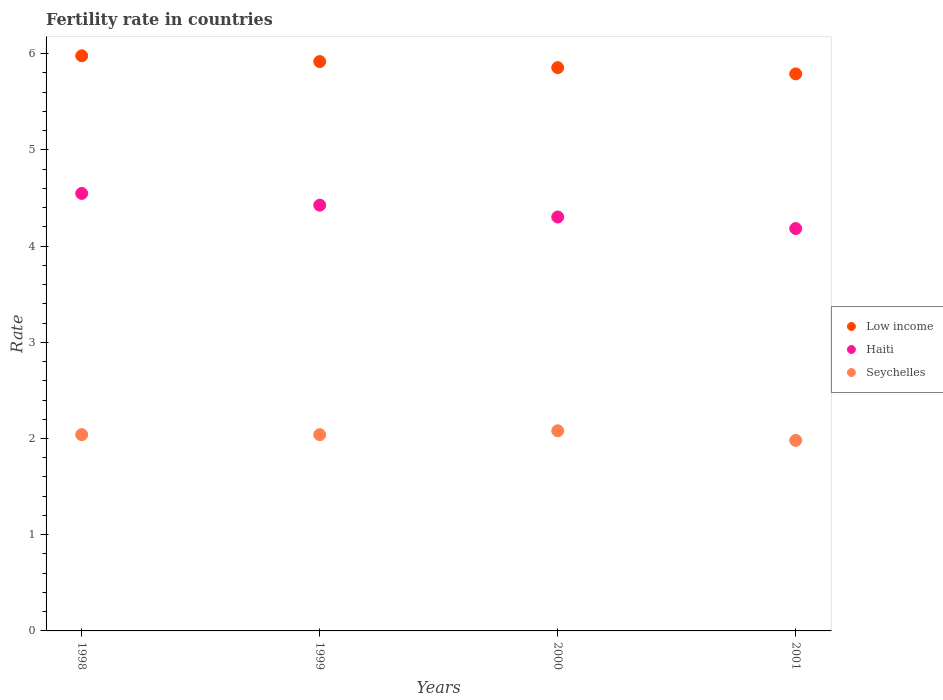Is the number of dotlines equal to the number of legend labels?
Your answer should be compact. Yes. What is the fertility rate in Haiti in 1998?
Your answer should be very brief. 4.55. Across all years, what is the maximum fertility rate in Seychelles?
Offer a terse response. 2.08. Across all years, what is the minimum fertility rate in Haiti?
Your answer should be compact. 4.18. In which year was the fertility rate in Low income minimum?
Your answer should be compact. 2001. What is the total fertility rate in Low income in the graph?
Provide a short and direct response. 23.54. What is the difference between the fertility rate in Haiti in 1999 and that in 2001?
Offer a very short reply. 0.24. What is the difference between the fertility rate in Haiti in 1999 and the fertility rate in Seychelles in 2000?
Provide a succinct answer. 2.34. What is the average fertility rate in Seychelles per year?
Make the answer very short. 2.04. In the year 1998, what is the difference between the fertility rate in Seychelles and fertility rate in Haiti?
Your answer should be compact. -2.51. In how many years, is the fertility rate in Seychelles greater than 0.6000000000000001?
Your answer should be very brief. 4. What is the ratio of the fertility rate in Low income in 1999 to that in 2000?
Keep it short and to the point. 1.01. What is the difference between the highest and the second highest fertility rate in Low income?
Your response must be concise. 0.06. What is the difference between the highest and the lowest fertility rate in Seychelles?
Offer a very short reply. 0.1. Is the sum of the fertility rate in Seychelles in 1998 and 2000 greater than the maximum fertility rate in Haiti across all years?
Offer a very short reply. No. Is it the case that in every year, the sum of the fertility rate in Haiti and fertility rate in Seychelles  is greater than the fertility rate in Low income?
Ensure brevity in your answer.  Yes. Does the fertility rate in Haiti monotonically increase over the years?
Keep it short and to the point. No. Is the fertility rate in Seychelles strictly greater than the fertility rate in Low income over the years?
Your answer should be compact. No. Is the fertility rate in Haiti strictly less than the fertility rate in Low income over the years?
Make the answer very short. Yes. How many years are there in the graph?
Offer a very short reply. 4. What is the difference between two consecutive major ticks on the Y-axis?
Make the answer very short. 1. Does the graph contain any zero values?
Ensure brevity in your answer.  No. Does the graph contain grids?
Provide a succinct answer. No. Where does the legend appear in the graph?
Ensure brevity in your answer.  Center right. What is the title of the graph?
Your answer should be very brief. Fertility rate in countries. Does "Guatemala" appear as one of the legend labels in the graph?
Offer a very short reply. No. What is the label or title of the Y-axis?
Your answer should be very brief. Rate. What is the Rate in Low income in 1998?
Your response must be concise. 5.98. What is the Rate of Haiti in 1998?
Provide a short and direct response. 4.55. What is the Rate in Seychelles in 1998?
Provide a succinct answer. 2.04. What is the Rate of Low income in 1999?
Give a very brief answer. 5.92. What is the Rate in Haiti in 1999?
Your answer should be very brief. 4.42. What is the Rate of Seychelles in 1999?
Offer a terse response. 2.04. What is the Rate of Low income in 2000?
Provide a succinct answer. 5.85. What is the Rate in Haiti in 2000?
Your answer should be compact. 4.3. What is the Rate of Seychelles in 2000?
Make the answer very short. 2.08. What is the Rate in Low income in 2001?
Make the answer very short. 5.79. What is the Rate of Haiti in 2001?
Your response must be concise. 4.18. What is the Rate in Seychelles in 2001?
Ensure brevity in your answer.  1.98. Across all years, what is the maximum Rate in Low income?
Offer a very short reply. 5.98. Across all years, what is the maximum Rate in Haiti?
Offer a terse response. 4.55. Across all years, what is the maximum Rate of Seychelles?
Keep it short and to the point. 2.08. Across all years, what is the minimum Rate in Low income?
Give a very brief answer. 5.79. Across all years, what is the minimum Rate of Haiti?
Make the answer very short. 4.18. Across all years, what is the minimum Rate in Seychelles?
Make the answer very short. 1.98. What is the total Rate in Low income in the graph?
Ensure brevity in your answer.  23.54. What is the total Rate of Haiti in the graph?
Keep it short and to the point. 17.46. What is the total Rate in Seychelles in the graph?
Make the answer very short. 8.14. What is the difference between the Rate in Low income in 1998 and that in 1999?
Your answer should be compact. 0.06. What is the difference between the Rate of Haiti in 1998 and that in 1999?
Your response must be concise. 0.12. What is the difference between the Rate in Low income in 1998 and that in 2000?
Offer a terse response. 0.12. What is the difference between the Rate of Haiti in 1998 and that in 2000?
Provide a succinct answer. 0.24. What is the difference between the Rate in Seychelles in 1998 and that in 2000?
Give a very brief answer. -0.04. What is the difference between the Rate of Low income in 1998 and that in 2001?
Provide a short and direct response. 0.19. What is the difference between the Rate of Haiti in 1998 and that in 2001?
Offer a very short reply. 0.36. What is the difference between the Rate of Low income in 1999 and that in 2000?
Offer a very short reply. 0.06. What is the difference between the Rate in Haiti in 1999 and that in 2000?
Provide a short and direct response. 0.12. What is the difference between the Rate of Seychelles in 1999 and that in 2000?
Provide a short and direct response. -0.04. What is the difference between the Rate of Low income in 1999 and that in 2001?
Make the answer very short. 0.13. What is the difference between the Rate in Haiti in 1999 and that in 2001?
Offer a terse response. 0.24. What is the difference between the Rate in Seychelles in 1999 and that in 2001?
Provide a short and direct response. 0.06. What is the difference between the Rate of Low income in 2000 and that in 2001?
Offer a very short reply. 0.07. What is the difference between the Rate in Haiti in 2000 and that in 2001?
Offer a terse response. 0.12. What is the difference between the Rate in Seychelles in 2000 and that in 2001?
Ensure brevity in your answer.  0.1. What is the difference between the Rate of Low income in 1998 and the Rate of Haiti in 1999?
Ensure brevity in your answer.  1.55. What is the difference between the Rate in Low income in 1998 and the Rate in Seychelles in 1999?
Give a very brief answer. 3.94. What is the difference between the Rate of Haiti in 1998 and the Rate of Seychelles in 1999?
Keep it short and to the point. 2.51. What is the difference between the Rate in Low income in 1998 and the Rate in Haiti in 2000?
Offer a terse response. 1.68. What is the difference between the Rate of Low income in 1998 and the Rate of Seychelles in 2000?
Offer a very short reply. 3.9. What is the difference between the Rate in Haiti in 1998 and the Rate in Seychelles in 2000?
Offer a very short reply. 2.47. What is the difference between the Rate in Low income in 1998 and the Rate in Haiti in 2001?
Keep it short and to the point. 1.8. What is the difference between the Rate of Low income in 1998 and the Rate of Seychelles in 2001?
Your answer should be compact. 4. What is the difference between the Rate of Haiti in 1998 and the Rate of Seychelles in 2001?
Your response must be concise. 2.57. What is the difference between the Rate in Low income in 1999 and the Rate in Haiti in 2000?
Ensure brevity in your answer.  1.62. What is the difference between the Rate of Low income in 1999 and the Rate of Seychelles in 2000?
Your response must be concise. 3.84. What is the difference between the Rate in Haiti in 1999 and the Rate in Seychelles in 2000?
Your answer should be compact. 2.35. What is the difference between the Rate of Low income in 1999 and the Rate of Haiti in 2001?
Ensure brevity in your answer.  1.74. What is the difference between the Rate of Low income in 1999 and the Rate of Seychelles in 2001?
Ensure brevity in your answer.  3.94. What is the difference between the Rate of Haiti in 1999 and the Rate of Seychelles in 2001?
Give a very brief answer. 2.44. What is the difference between the Rate of Low income in 2000 and the Rate of Haiti in 2001?
Your answer should be very brief. 1.67. What is the difference between the Rate in Low income in 2000 and the Rate in Seychelles in 2001?
Offer a very short reply. 3.87. What is the difference between the Rate in Haiti in 2000 and the Rate in Seychelles in 2001?
Your answer should be very brief. 2.32. What is the average Rate of Low income per year?
Your response must be concise. 5.88. What is the average Rate of Haiti per year?
Provide a succinct answer. 4.36. What is the average Rate of Seychelles per year?
Your response must be concise. 2.04. In the year 1998, what is the difference between the Rate in Low income and Rate in Haiti?
Provide a short and direct response. 1.43. In the year 1998, what is the difference between the Rate of Low income and Rate of Seychelles?
Keep it short and to the point. 3.94. In the year 1998, what is the difference between the Rate in Haiti and Rate in Seychelles?
Offer a terse response. 2.51. In the year 1999, what is the difference between the Rate of Low income and Rate of Haiti?
Offer a very short reply. 1.49. In the year 1999, what is the difference between the Rate in Low income and Rate in Seychelles?
Make the answer very short. 3.88. In the year 1999, what is the difference between the Rate in Haiti and Rate in Seychelles?
Your answer should be compact. 2.38. In the year 2000, what is the difference between the Rate of Low income and Rate of Haiti?
Make the answer very short. 1.55. In the year 2000, what is the difference between the Rate in Low income and Rate in Seychelles?
Ensure brevity in your answer.  3.77. In the year 2000, what is the difference between the Rate in Haiti and Rate in Seychelles?
Offer a terse response. 2.22. In the year 2001, what is the difference between the Rate of Low income and Rate of Haiti?
Your response must be concise. 1.61. In the year 2001, what is the difference between the Rate of Low income and Rate of Seychelles?
Ensure brevity in your answer.  3.81. In the year 2001, what is the difference between the Rate in Haiti and Rate in Seychelles?
Offer a terse response. 2.2. What is the ratio of the Rate of Low income in 1998 to that in 1999?
Give a very brief answer. 1.01. What is the ratio of the Rate of Haiti in 1998 to that in 1999?
Ensure brevity in your answer.  1.03. What is the ratio of the Rate in Haiti in 1998 to that in 2000?
Provide a succinct answer. 1.06. What is the ratio of the Rate in Seychelles in 1998 to that in 2000?
Offer a terse response. 0.98. What is the ratio of the Rate of Low income in 1998 to that in 2001?
Offer a very short reply. 1.03. What is the ratio of the Rate in Haiti in 1998 to that in 2001?
Ensure brevity in your answer.  1.09. What is the ratio of the Rate in Seychelles in 1998 to that in 2001?
Provide a succinct answer. 1.03. What is the ratio of the Rate in Low income in 1999 to that in 2000?
Offer a terse response. 1.01. What is the ratio of the Rate of Haiti in 1999 to that in 2000?
Your answer should be compact. 1.03. What is the ratio of the Rate in Seychelles in 1999 to that in 2000?
Provide a short and direct response. 0.98. What is the ratio of the Rate in Low income in 1999 to that in 2001?
Make the answer very short. 1.02. What is the ratio of the Rate in Haiti in 1999 to that in 2001?
Your answer should be very brief. 1.06. What is the ratio of the Rate in Seychelles in 1999 to that in 2001?
Your response must be concise. 1.03. What is the ratio of the Rate of Low income in 2000 to that in 2001?
Your answer should be compact. 1.01. What is the ratio of the Rate in Haiti in 2000 to that in 2001?
Your response must be concise. 1.03. What is the ratio of the Rate in Seychelles in 2000 to that in 2001?
Offer a very short reply. 1.05. What is the difference between the highest and the second highest Rate in Low income?
Provide a succinct answer. 0.06. What is the difference between the highest and the second highest Rate of Haiti?
Make the answer very short. 0.12. What is the difference between the highest and the second highest Rate in Seychelles?
Your answer should be very brief. 0.04. What is the difference between the highest and the lowest Rate in Low income?
Your answer should be very brief. 0.19. What is the difference between the highest and the lowest Rate of Haiti?
Your response must be concise. 0.36. 